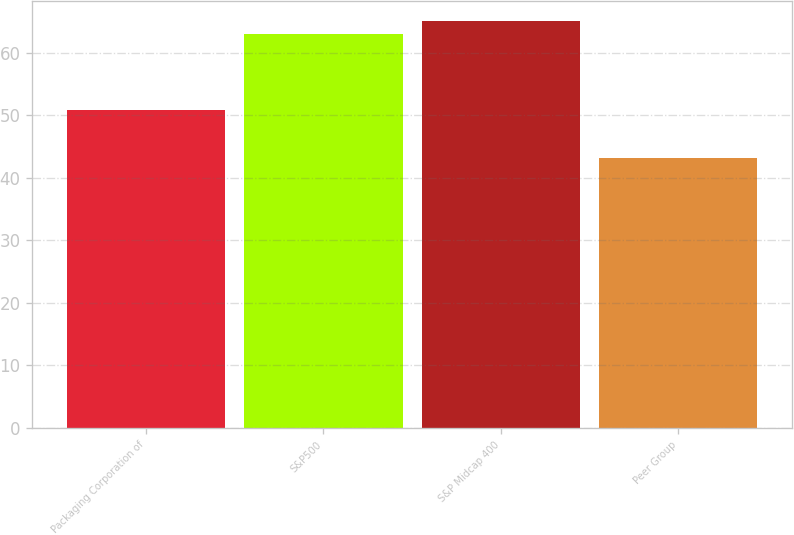<chart> <loc_0><loc_0><loc_500><loc_500><bar_chart><fcel>Packaging Corporation of<fcel>S&P500<fcel>S&P Midcap 400<fcel>Peer Group<nl><fcel>50.77<fcel>63<fcel>65.06<fcel>43.13<nl></chart> 